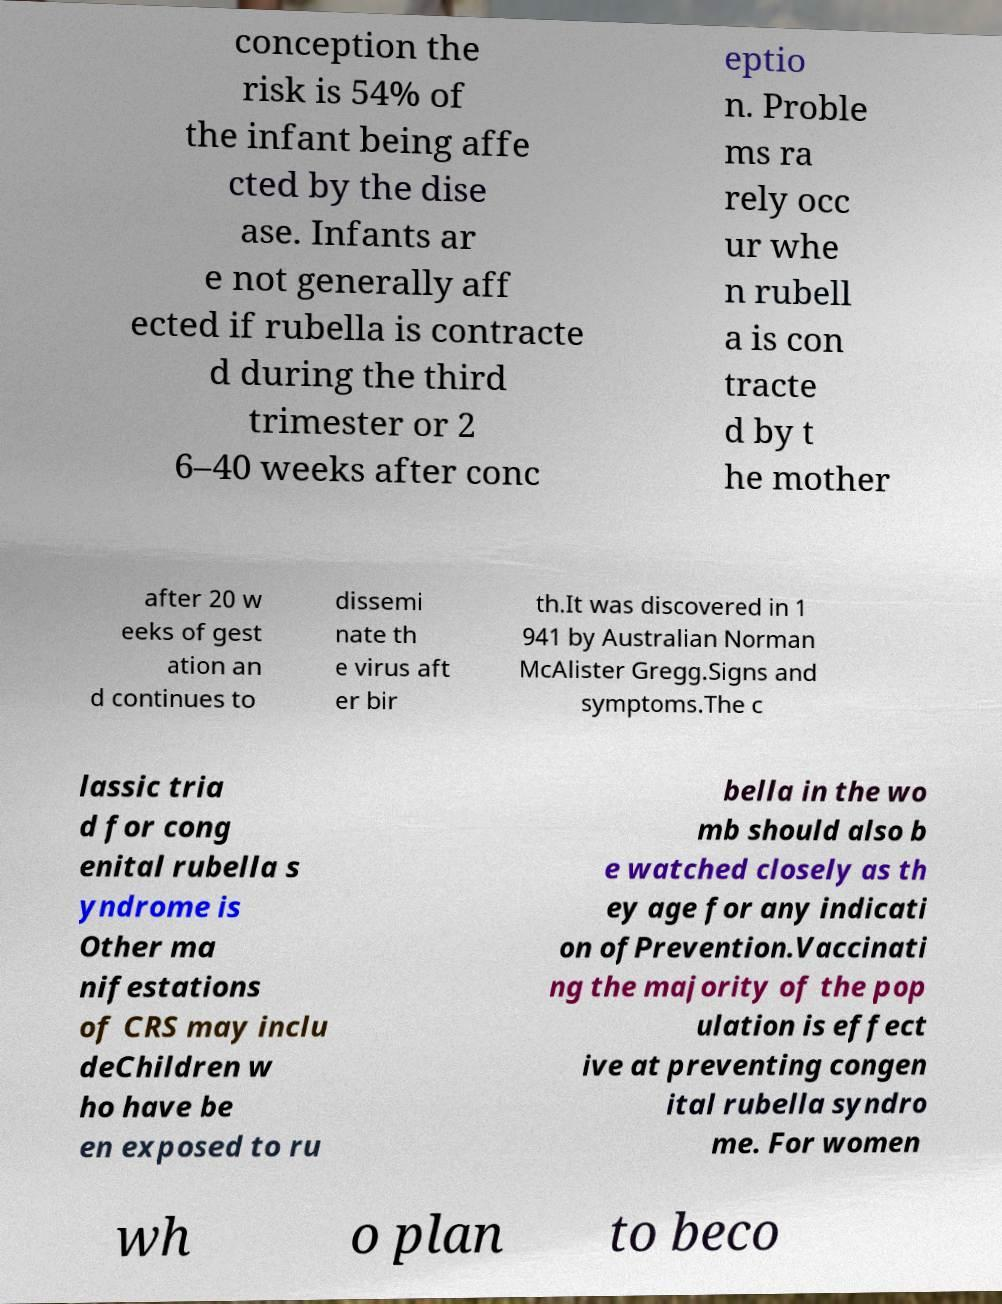Could you assist in decoding the text presented in this image and type it out clearly? conception the risk is 54% of the infant being affe cted by the dise ase. Infants ar e not generally aff ected if rubella is contracte d during the third trimester or 2 6–40 weeks after conc eptio n. Proble ms ra rely occ ur whe n rubell a is con tracte d by t he mother after 20 w eeks of gest ation an d continues to dissemi nate th e virus aft er bir th.It was discovered in 1 941 by Australian Norman McAlister Gregg.Signs and symptoms.The c lassic tria d for cong enital rubella s yndrome is Other ma nifestations of CRS may inclu deChildren w ho have be en exposed to ru bella in the wo mb should also b e watched closely as th ey age for any indicati on ofPrevention.Vaccinati ng the majority of the pop ulation is effect ive at preventing congen ital rubella syndro me. For women wh o plan to beco 